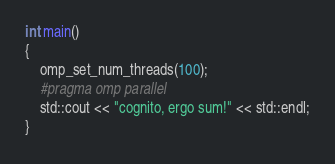Convert code to text. <code><loc_0><loc_0><loc_500><loc_500><_C++_>int main()
{
	omp_set_num_threads(100);
	#pragma omp parallel
	std::cout << "cognito, ergo sum!" << std::endl;
}
</code> 